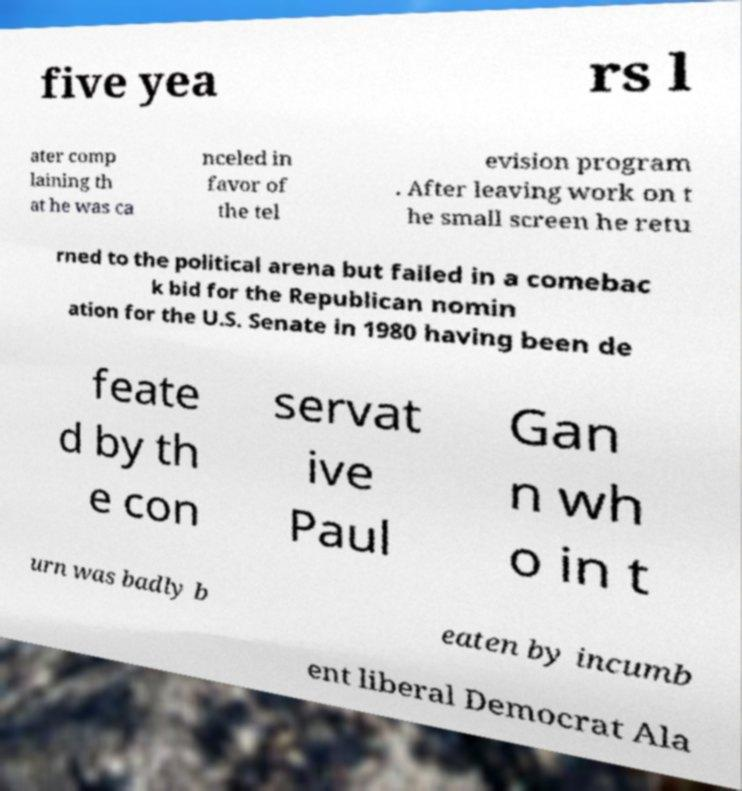Could you assist in decoding the text presented in this image and type it out clearly? five yea rs l ater comp laining th at he was ca nceled in favor of the tel evision program . After leaving work on t he small screen he retu rned to the political arena but failed in a comebac k bid for the Republican nomin ation for the U.S. Senate in 1980 having been de feate d by th e con servat ive Paul Gan n wh o in t urn was badly b eaten by incumb ent liberal Democrat Ala 